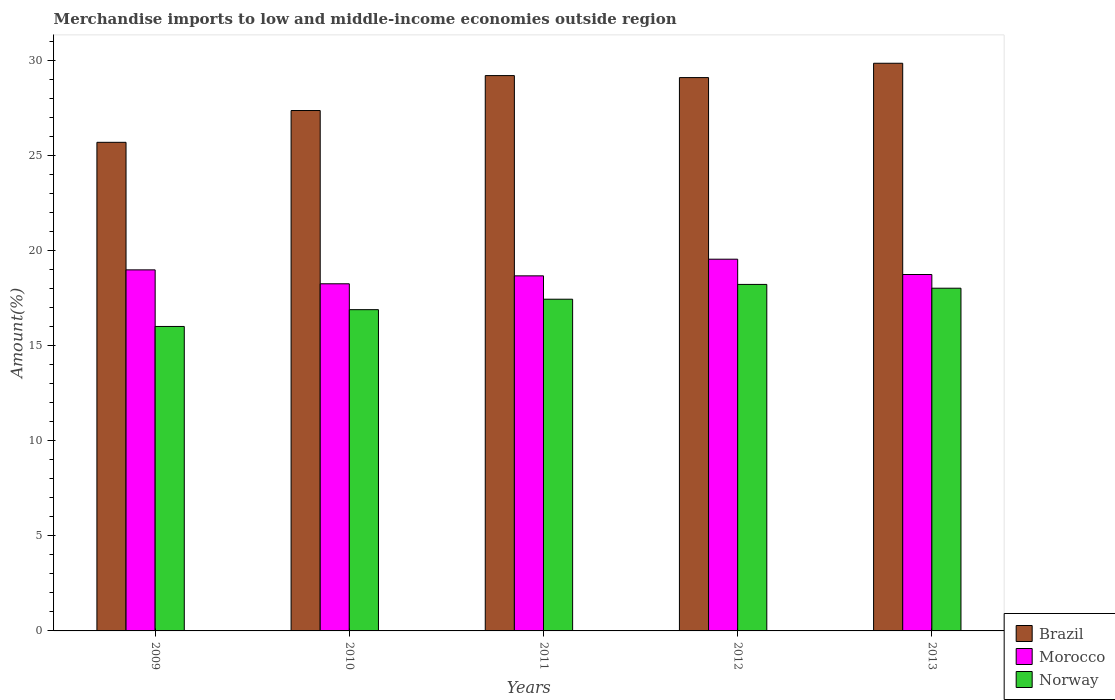How many different coloured bars are there?
Offer a terse response. 3. Are the number of bars per tick equal to the number of legend labels?
Your answer should be compact. Yes. Are the number of bars on each tick of the X-axis equal?
Provide a succinct answer. Yes. How many bars are there on the 3rd tick from the left?
Provide a short and direct response. 3. How many bars are there on the 4th tick from the right?
Give a very brief answer. 3. What is the percentage of amount earned from merchandise imports in Norway in 2009?
Your response must be concise. 16.01. Across all years, what is the maximum percentage of amount earned from merchandise imports in Morocco?
Your answer should be compact. 19.55. Across all years, what is the minimum percentage of amount earned from merchandise imports in Norway?
Your answer should be compact. 16.01. What is the total percentage of amount earned from merchandise imports in Brazil in the graph?
Keep it short and to the point. 141.21. What is the difference between the percentage of amount earned from merchandise imports in Morocco in 2009 and that in 2010?
Provide a short and direct response. 0.73. What is the difference between the percentage of amount earned from merchandise imports in Norway in 2011 and the percentage of amount earned from merchandise imports in Morocco in 2013?
Your response must be concise. -1.3. What is the average percentage of amount earned from merchandise imports in Brazil per year?
Your response must be concise. 28.24. In the year 2013, what is the difference between the percentage of amount earned from merchandise imports in Brazil and percentage of amount earned from merchandise imports in Morocco?
Your response must be concise. 11.11. In how many years, is the percentage of amount earned from merchandise imports in Morocco greater than 1 %?
Offer a very short reply. 5. What is the ratio of the percentage of amount earned from merchandise imports in Norway in 2011 to that in 2012?
Offer a very short reply. 0.96. What is the difference between the highest and the second highest percentage of amount earned from merchandise imports in Morocco?
Your answer should be compact. 0.56. What is the difference between the highest and the lowest percentage of amount earned from merchandise imports in Morocco?
Provide a short and direct response. 1.29. What does the 3rd bar from the right in 2012 represents?
Your response must be concise. Brazil. How many bars are there?
Your response must be concise. 15. How many years are there in the graph?
Provide a succinct answer. 5. What is the difference between two consecutive major ticks on the Y-axis?
Offer a terse response. 5. Are the values on the major ticks of Y-axis written in scientific E-notation?
Offer a very short reply. No. Where does the legend appear in the graph?
Offer a terse response. Bottom right. How many legend labels are there?
Your answer should be very brief. 3. What is the title of the graph?
Give a very brief answer. Merchandise imports to low and middle-income economies outside region. What is the label or title of the X-axis?
Your answer should be very brief. Years. What is the label or title of the Y-axis?
Provide a succinct answer. Amount(%). What is the Amount(%) of Brazil in 2009?
Give a very brief answer. 25.69. What is the Amount(%) in Morocco in 2009?
Keep it short and to the point. 18.99. What is the Amount(%) in Norway in 2009?
Provide a short and direct response. 16.01. What is the Amount(%) in Brazil in 2010?
Offer a terse response. 27.37. What is the Amount(%) in Morocco in 2010?
Provide a succinct answer. 18.25. What is the Amount(%) of Norway in 2010?
Provide a short and direct response. 16.89. What is the Amount(%) of Brazil in 2011?
Offer a terse response. 29.2. What is the Amount(%) of Morocco in 2011?
Ensure brevity in your answer.  18.67. What is the Amount(%) in Norway in 2011?
Make the answer very short. 17.44. What is the Amount(%) in Brazil in 2012?
Make the answer very short. 29.1. What is the Amount(%) of Morocco in 2012?
Make the answer very short. 19.55. What is the Amount(%) in Norway in 2012?
Give a very brief answer. 18.22. What is the Amount(%) in Brazil in 2013?
Give a very brief answer. 29.85. What is the Amount(%) in Morocco in 2013?
Your response must be concise. 18.74. What is the Amount(%) in Norway in 2013?
Provide a succinct answer. 18.02. Across all years, what is the maximum Amount(%) of Brazil?
Provide a succinct answer. 29.85. Across all years, what is the maximum Amount(%) of Morocco?
Your answer should be very brief. 19.55. Across all years, what is the maximum Amount(%) of Norway?
Make the answer very short. 18.22. Across all years, what is the minimum Amount(%) of Brazil?
Provide a short and direct response. 25.69. Across all years, what is the minimum Amount(%) of Morocco?
Your answer should be compact. 18.25. Across all years, what is the minimum Amount(%) in Norway?
Make the answer very short. 16.01. What is the total Amount(%) of Brazil in the graph?
Provide a short and direct response. 141.21. What is the total Amount(%) of Morocco in the graph?
Your response must be concise. 94.2. What is the total Amount(%) of Norway in the graph?
Offer a very short reply. 86.59. What is the difference between the Amount(%) in Brazil in 2009 and that in 2010?
Your answer should be very brief. -1.67. What is the difference between the Amount(%) of Morocco in 2009 and that in 2010?
Your answer should be very brief. 0.73. What is the difference between the Amount(%) in Norway in 2009 and that in 2010?
Keep it short and to the point. -0.88. What is the difference between the Amount(%) of Brazil in 2009 and that in 2011?
Your response must be concise. -3.51. What is the difference between the Amount(%) in Morocco in 2009 and that in 2011?
Ensure brevity in your answer.  0.32. What is the difference between the Amount(%) in Norway in 2009 and that in 2011?
Keep it short and to the point. -1.43. What is the difference between the Amount(%) in Brazil in 2009 and that in 2012?
Offer a very short reply. -3.4. What is the difference between the Amount(%) of Morocco in 2009 and that in 2012?
Your response must be concise. -0.56. What is the difference between the Amount(%) of Norway in 2009 and that in 2012?
Offer a very short reply. -2.21. What is the difference between the Amount(%) of Brazil in 2009 and that in 2013?
Keep it short and to the point. -4.16. What is the difference between the Amount(%) in Morocco in 2009 and that in 2013?
Keep it short and to the point. 0.24. What is the difference between the Amount(%) of Norway in 2009 and that in 2013?
Offer a very short reply. -2.01. What is the difference between the Amount(%) in Brazil in 2010 and that in 2011?
Your response must be concise. -1.84. What is the difference between the Amount(%) in Morocco in 2010 and that in 2011?
Provide a short and direct response. -0.42. What is the difference between the Amount(%) in Norway in 2010 and that in 2011?
Give a very brief answer. -0.55. What is the difference between the Amount(%) in Brazil in 2010 and that in 2012?
Make the answer very short. -1.73. What is the difference between the Amount(%) in Morocco in 2010 and that in 2012?
Your response must be concise. -1.29. What is the difference between the Amount(%) in Norway in 2010 and that in 2012?
Provide a succinct answer. -1.33. What is the difference between the Amount(%) of Brazil in 2010 and that in 2013?
Provide a short and direct response. -2.49. What is the difference between the Amount(%) in Morocco in 2010 and that in 2013?
Offer a terse response. -0.49. What is the difference between the Amount(%) of Norway in 2010 and that in 2013?
Provide a short and direct response. -1.13. What is the difference between the Amount(%) of Brazil in 2011 and that in 2012?
Keep it short and to the point. 0.1. What is the difference between the Amount(%) of Morocco in 2011 and that in 2012?
Offer a terse response. -0.88. What is the difference between the Amount(%) of Norway in 2011 and that in 2012?
Your answer should be compact. -0.78. What is the difference between the Amount(%) of Brazil in 2011 and that in 2013?
Keep it short and to the point. -0.65. What is the difference between the Amount(%) of Morocco in 2011 and that in 2013?
Give a very brief answer. -0.07. What is the difference between the Amount(%) of Norway in 2011 and that in 2013?
Give a very brief answer. -0.58. What is the difference between the Amount(%) in Brazil in 2012 and that in 2013?
Ensure brevity in your answer.  -0.75. What is the difference between the Amount(%) of Morocco in 2012 and that in 2013?
Keep it short and to the point. 0.8. What is the difference between the Amount(%) in Norway in 2012 and that in 2013?
Make the answer very short. 0.2. What is the difference between the Amount(%) in Brazil in 2009 and the Amount(%) in Morocco in 2010?
Your answer should be very brief. 7.44. What is the difference between the Amount(%) in Brazil in 2009 and the Amount(%) in Norway in 2010?
Offer a very short reply. 8.8. What is the difference between the Amount(%) of Morocco in 2009 and the Amount(%) of Norway in 2010?
Make the answer very short. 2.09. What is the difference between the Amount(%) of Brazil in 2009 and the Amount(%) of Morocco in 2011?
Your answer should be compact. 7.02. What is the difference between the Amount(%) in Brazil in 2009 and the Amount(%) in Norway in 2011?
Your answer should be compact. 8.25. What is the difference between the Amount(%) in Morocco in 2009 and the Amount(%) in Norway in 2011?
Ensure brevity in your answer.  1.54. What is the difference between the Amount(%) in Brazil in 2009 and the Amount(%) in Morocco in 2012?
Ensure brevity in your answer.  6.15. What is the difference between the Amount(%) of Brazil in 2009 and the Amount(%) of Norway in 2012?
Your answer should be compact. 7.47. What is the difference between the Amount(%) in Morocco in 2009 and the Amount(%) in Norway in 2012?
Keep it short and to the point. 0.77. What is the difference between the Amount(%) in Brazil in 2009 and the Amount(%) in Morocco in 2013?
Offer a terse response. 6.95. What is the difference between the Amount(%) of Brazil in 2009 and the Amount(%) of Norway in 2013?
Offer a very short reply. 7.67. What is the difference between the Amount(%) in Morocco in 2009 and the Amount(%) in Norway in 2013?
Give a very brief answer. 0.97. What is the difference between the Amount(%) of Brazil in 2010 and the Amount(%) of Morocco in 2011?
Provide a short and direct response. 8.69. What is the difference between the Amount(%) in Brazil in 2010 and the Amount(%) in Norway in 2011?
Keep it short and to the point. 9.92. What is the difference between the Amount(%) in Morocco in 2010 and the Amount(%) in Norway in 2011?
Your answer should be very brief. 0.81. What is the difference between the Amount(%) of Brazil in 2010 and the Amount(%) of Morocco in 2012?
Provide a short and direct response. 7.82. What is the difference between the Amount(%) in Brazil in 2010 and the Amount(%) in Norway in 2012?
Provide a succinct answer. 9.14. What is the difference between the Amount(%) in Morocco in 2010 and the Amount(%) in Norway in 2012?
Your response must be concise. 0.03. What is the difference between the Amount(%) of Brazil in 2010 and the Amount(%) of Morocco in 2013?
Provide a short and direct response. 8.62. What is the difference between the Amount(%) of Brazil in 2010 and the Amount(%) of Norway in 2013?
Your response must be concise. 9.34. What is the difference between the Amount(%) of Morocco in 2010 and the Amount(%) of Norway in 2013?
Provide a succinct answer. 0.23. What is the difference between the Amount(%) in Brazil in 2011 and the Amount(%) in Morocco in 2012?
Your response must be concise. 9.65. What is the difference between the Amount(%) in Brazil in 2011 and the Amount(%) in Norway in 2012?
Offer a very short reply. 10.98. What is the difference between the Amount(%) in Morocco in 2011 and the Amount(%) in Norway in 2012?
Your answer should be very brief. 0.45. What is the difference between the Amount(%) in Brazil in 2011 and the Amount(%) in Morocco in 2013?
Make the answer very short. 10.46. What is the difference between the Amount(%) in Brazil in 2011 and the Amount(%) in Norway in 2013?
Offer a terse response. 11.18. What is the difference between the Amount(%) of Morocco in 2011 and the Amount(%) of Norway in 2013?
Offer a very short reply. 0.65. What is the difference between the Amount(%) in Brazil in 2012 and the Amount(%) in Morocco in 2013?
Offer a very short reply. 10.35. What is the difference between the Amount(%) in Brazil in 2012 and the Amount(%) in Norway in 2013?
Your answer should be very brief. 11.08. What is the difference between the Amount(%) in Morocco in 2012 and the Amount(%) in Norway in 2013?
Ensure brevity in your answer.  1.53. What is the average Amount(%) in Brazil per year?
Ensure brevity in your answer.  28.24. What is the average Amount(%) in Morocco per year?
Give a very brief answer. 18.84. What is the average Amount(%) of Norway per year?
Your response must be concise. 17.32. In the year 2009, what is the difference between the Amount(%) of Brazil and Amount(%) of Morocco?
Give a very brief answer. 6.71. In the year 2009, what is the difference between the Amount(%) in Brazil and Amount(%) in Norway?
Your response must be concise. 9.68. In the year 2009, what is the difference between the Amount(%) in Morocco and Amount(%) in Norway?
Offer a terse response. 2.98. In the year 2010, what is the difference between the Amount(%) in Brazil and Amount(%) in Morocco?
Provide a succinct answer. 9.11. In the year 2010, what is the difference between the Amount(%) in Brazil and Amount(%) in Norway?
Your answer should be very brief. 10.47. In the year 2010, what is the difference between the Amount(%) in Morocco and Amount(%) in Norway?
Give a very brief answer. 1.36. In the year 2011, what is the difference between the Amount(%) of Brazil and Amount(%) of Morocco?
Ensure brevity in your answer.  10.53. In the year 2011, what is the difference between the Amount(%) of Brazil and Amount(%) of Norway?
Offer a terse response. 11.76. In the year 2011, what is the difference between the Amount(%) in Morocco and Amount(%) in Norway?
Your answer should be compact. 1.23. In the year 2012, what is the difference between the Amount(%) of Brazil and Amount(%) of Morocco?
Provide a short and direct response. 9.55. In the year 2012, what is the difference between the Amount(%) in Brazil and Amount(%) in Norway?
Your answer should be very brief. 10.88. In the year 2012, what is the difference between the Amount(%) of Morocco and Amount(%) of Norway?
Offer a terse response. 1.33. In the year 2013, what is the difference between the Amount(%) of Brazil and Amount(%) of Morocco?
Keep it short and to the point. 11.11. In the year 2013, what is the difference between the Amount(%) in Brazil and Amount(%) in Norway?
Your answer should be compact. 11.83. In the year 2013, what is the difference between the Amount(%) in Morocco and Amount(%) in Norway?
Your response must be concise. 0.72. What is the ratio of the Amount(%) of Brazil in 2009 to that in 2010?
Make the answer very short. 0.94. What is the ratio of the Amount(%) of Morocco in 2009 to that in 2010?
Your answer should be very brief. 1.04. What is the ratio of the Amount(%) in Norway in 2009 to that in 2010?
Your response must be concise. 0.95. What is the ratio of the Amount(%) in Brazil in 2009 to that in 2011?
Provide a succinct answer. 0.88. What is the ratio of the Amount(%) in Morocco in 2009 to that in 2011?
Give a very brief answer. 1.02. What is the ratio of the Amount(%) in Norway in 2009 to that in 2011?
Make the answer very short. 0.92. What is the ratio of the Amount(%) of Brazil in 2009 to that in 2012?
Keep it short and to the point. 0.88. What is the ratio of the Amount(%) of Morocco in 2009 to that in 2012?
Your answer should be compact. 0.97. What is the ratio of the Amount(%) of Norway in 2009 to that in 2012?
Provide a short and direct response. 0.88. What is the ratio of the Amount(%) in Brazil in 2009 to that in 2013?
Your answer should be compact. 0.86. What is the ratio of the Amount(%) of Norway in 2009 to that in 2013?
Offer a very short reply. 0.89. What is the ratio of the Amount(%) of Brazil in 2010 to that in 2011?
Offer a terse response. 0.94. What is the ratio of the Amount(%) in Morocco in 2010 to that in 2011?
Provide a succinct answer. 0.98. What is the ratio of the Amount(%) in Norway in 2010 to that in 2011?
Provide a succinct answer. 0.97. What is the ratio of the Amount(%) in Brazil in 2010 to that in 2012?
Your response must be concise. 0.94. What is the ratio of the Amount(%) in Morocco in 2010 to that in 2012?
Provide a succinct answer. 0.93. What is the ratio of the Amount(%) of Norway in 2010 to that in 2012?
Your answer should be very brief. 0.93. What is the ratio of the Amount(%) in Morocco in 2010 to that in 2013?
Ensure brevity in your answer.  0.97. What is the ratio of the Amount(%) of Norway in 2010 to that in 2013?
Your answer should be compact. 0.94. What is the ratio of the Amount(%) in Morocco in 2011 to that in 2012?
Give a very brief answer. 0.96. What is the ratio of the Amount(%) of Norway in 2011 to that in 2012?
Provide a short and direct response. 0.96. What is the ratio of the Amount(%) in Brazil in 2011 to that in 2013?
Your answer should be compact. 0.98. What is the ratio of the Amount(%) of Norway in 2011 to that in 2013?
Your response must be concise. 0.97. What is the ratio of the Amount(%) in Brazil in 2012 to that in 2013?
Provide a short and direct response. 0.97. What is the ratio of the Amount(%) of Morocco in 2012 to that in 2013?
Your answer should be very brief. 1.04. What is the ratio of the Amount(%) of Norway in 2012 to that in 2013?
Provide a short and direct response. 1.01. What is the difference between the highest and the second highest Amount(%) in Brazil?
Your answer should be compact. 0.65. What is the difference between the highest and the second highest Amount(%) of Morocco?
Provide a short and direct response. 0.56. What is the difference between the highest and the second highest Amount(%) in Norway?
Give a very brief answer. 0.2. What is the difference between the highest and the lowest Amount(%) in Brazil?
Your response must be concise. 4.16. What is the difference between the highest and the lowest Amount(%) in Morocco?
Your response must be concise. 1.29. What is the difference between the highest and the lowest Amount(%) in Norway?
Your answer should be compact. 2.21. 